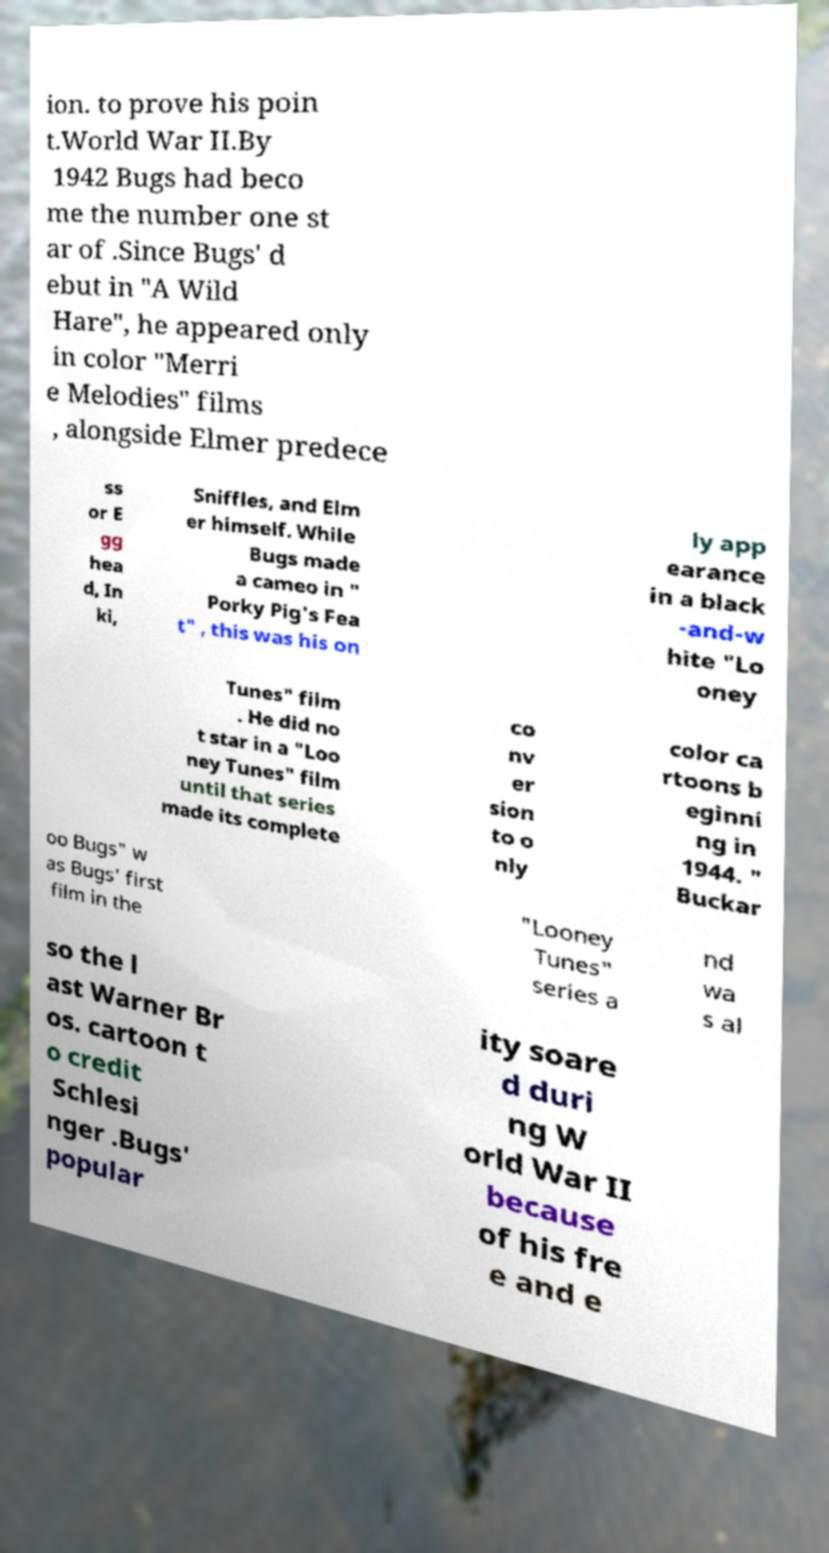Please read and relay the text visible in this image. What does it say? ion. to prove his poin t.World War II.By 1942 Bugs had beco me the number one st ar of .Since Bugs' d ebut in "A Wild Hare", he appeared only in color "Merri e Melodies" films , alongside Elmer predece ss or E gg hea d, In ki, Sniffles, and Elm er himself. While Bugs made a cameo in " Porky Pig's Fea t" , this was his on ly app earance in a black -and-w hite "Lo oney Tunes" film . He did no t star in a "Loo ney Tunes" film until that series made its complete co nv er sion to o nly color ca rtoons b eginni ng in 1944. " Buckar oo Bugs" w as Bugs' first film in the "Looney Tunes" series a nd wa s al so the l ast Warner Br os. cartoon t o credit Schlesi nger .Bugs' popular ity soare d duri ng W orld War II because of his fre e and e 